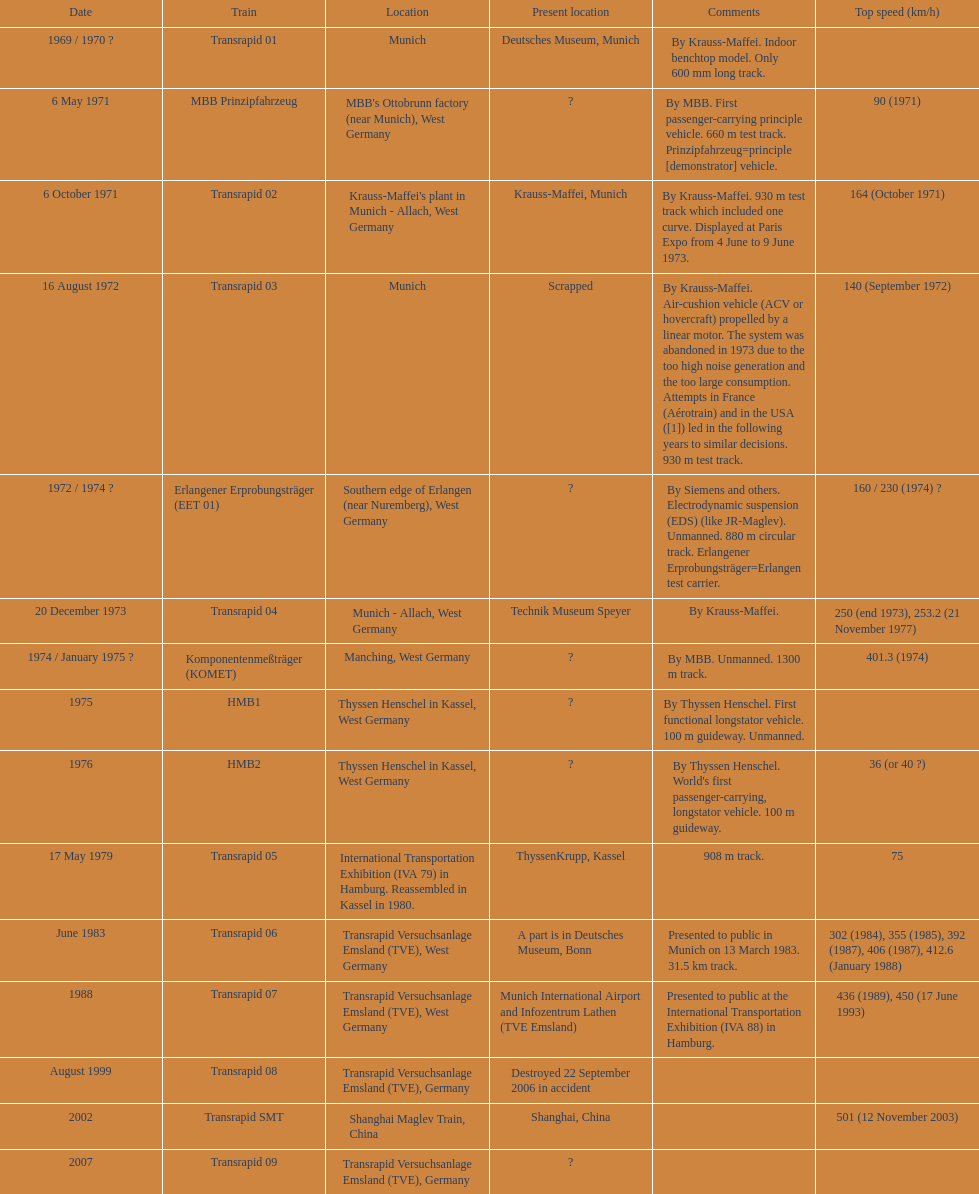What is the number of trains that were either scrapped or destroyed? 2. 